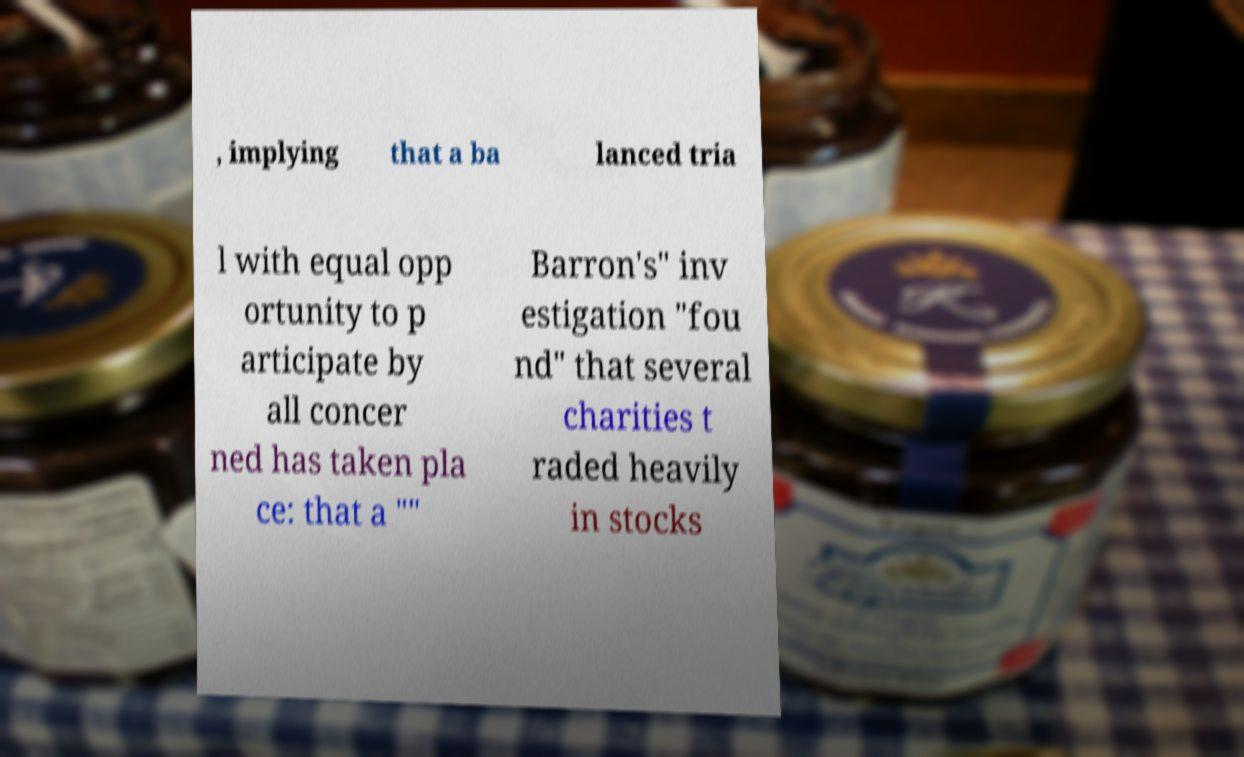What messages or text are displayed in this image? I need them in a readable, typed format. , implying that a ba lanced tria l with equal opp ortunity to p articipate by all concer ned has taken pla ce: that a "" Barron's" inv estigation "fou nd" that several charities t raded heavily in stocks 